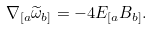<formula> <loc_0><loc_0><loc_500><loc_500>\nabla _ { [ a } \widetilde { \omega } _ { b ] } = - 4 E _ { [ a } B _ { b ] } .</formula> 